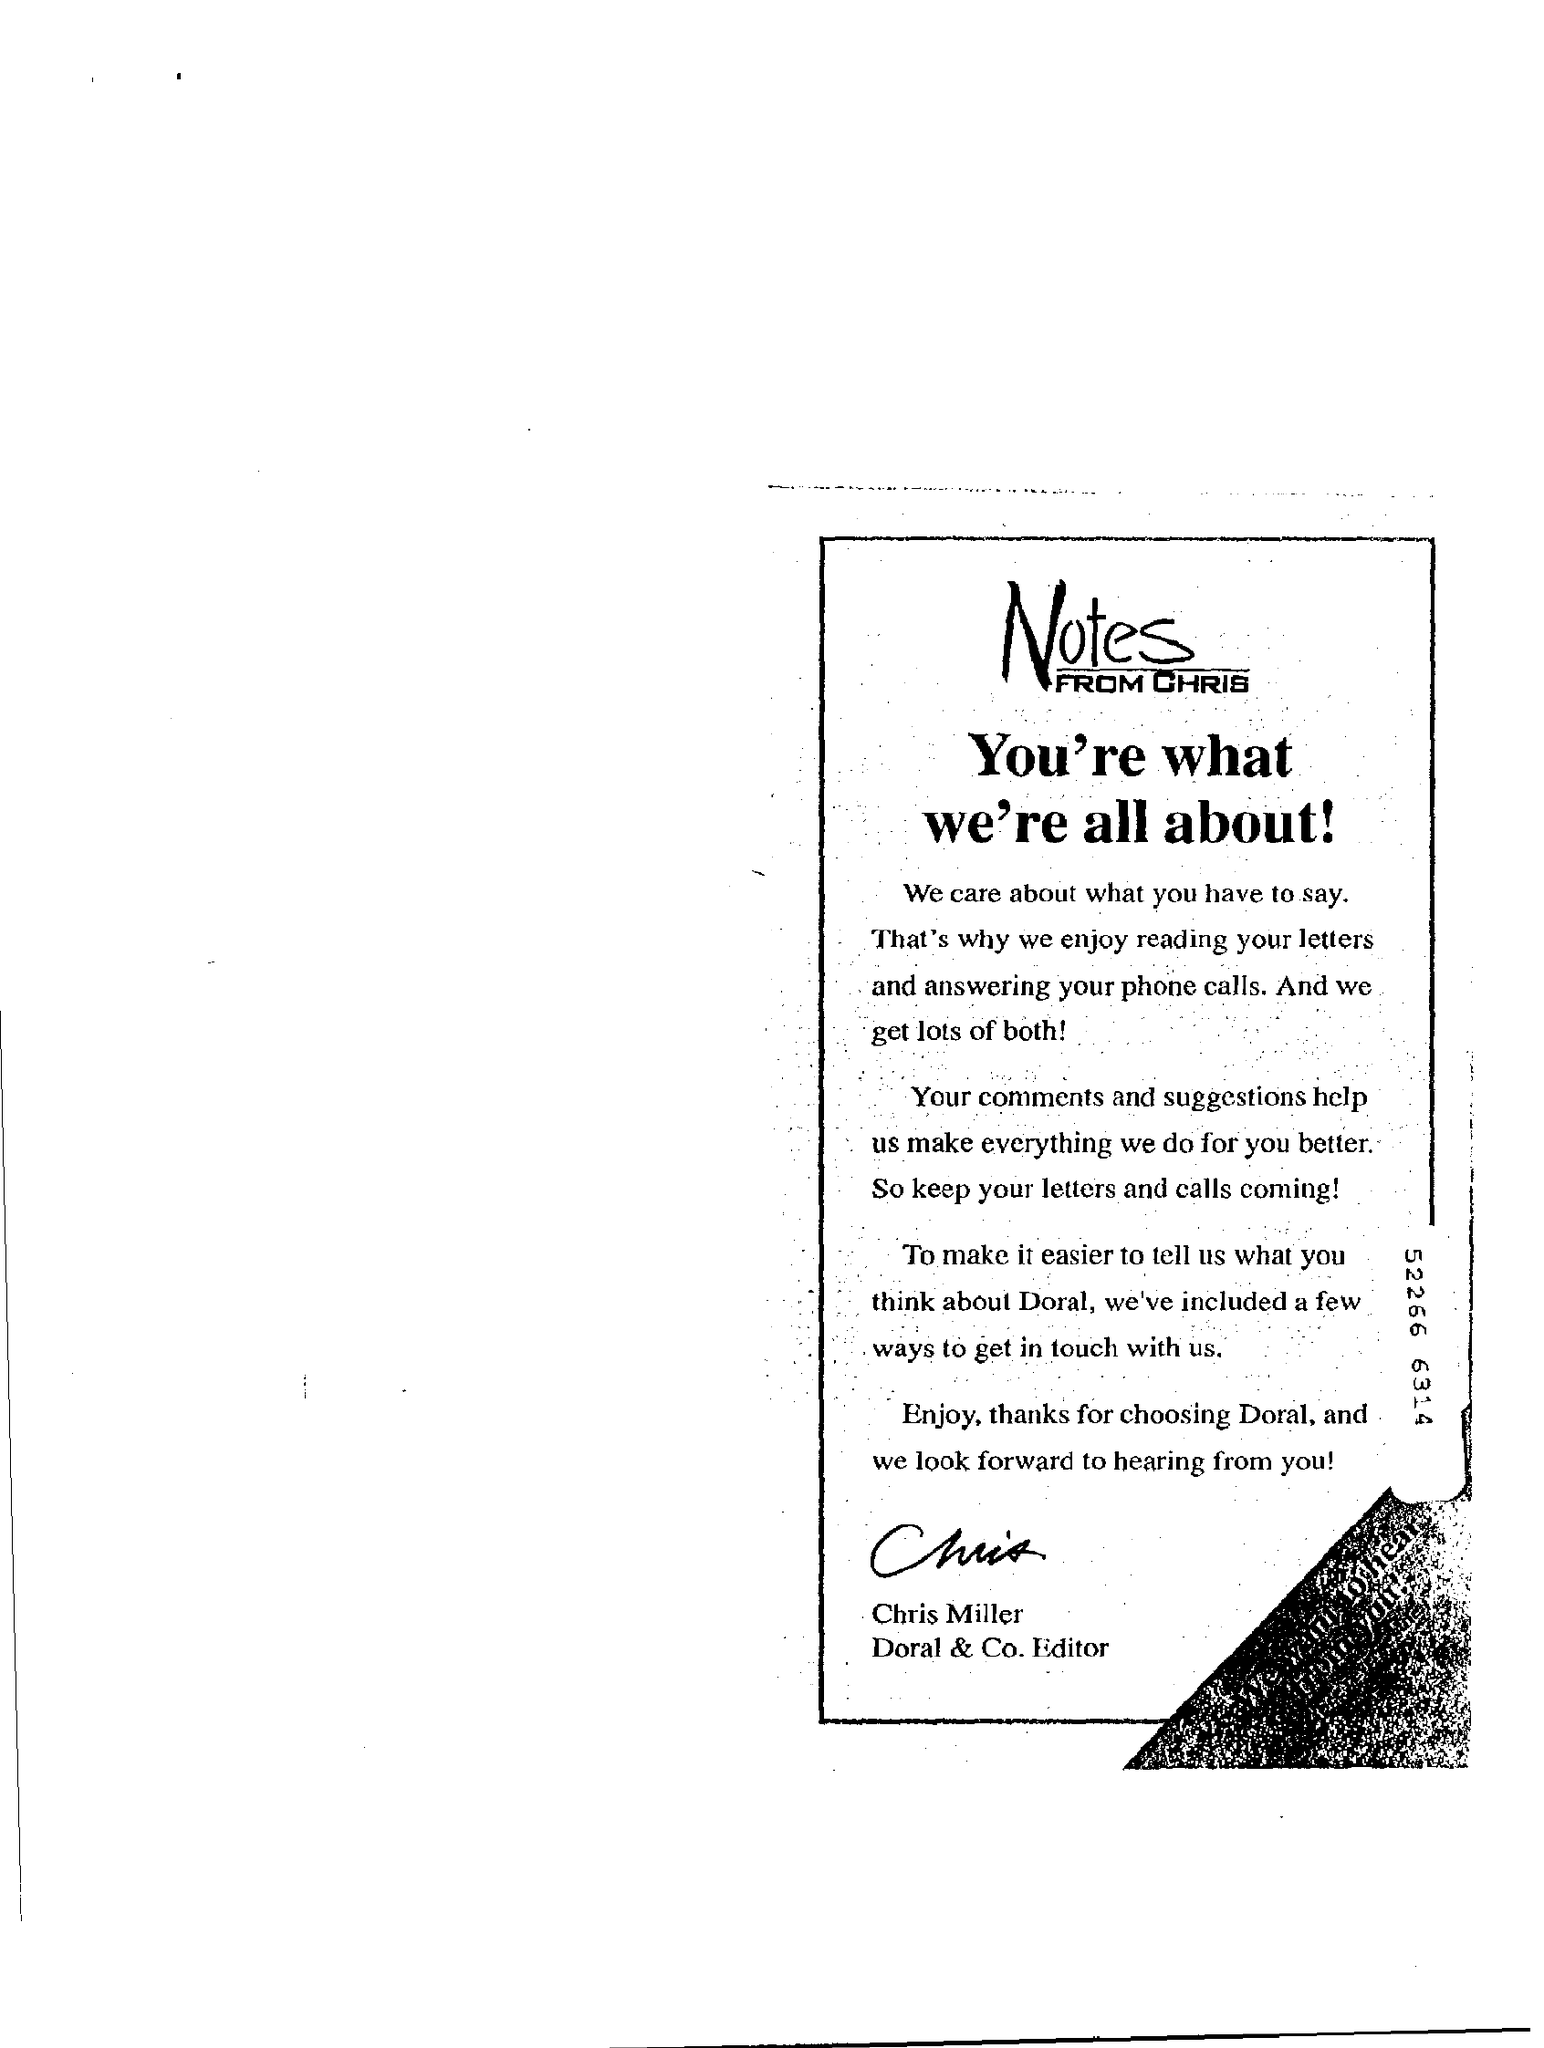Indicate a few pertinent items in this graphic. The number 52,266 is given on the right side of the page, followed by the numbers 6,314. Notes from Chris" is the title given to what we're all about! Thanks for choosing [whom is mentioned in the "Notes"] Doral. The author of "Notes" is listed as CHRIS. 